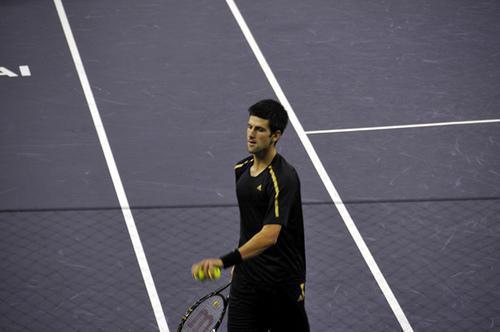How many balls?
Give a very brief answer. 2. 